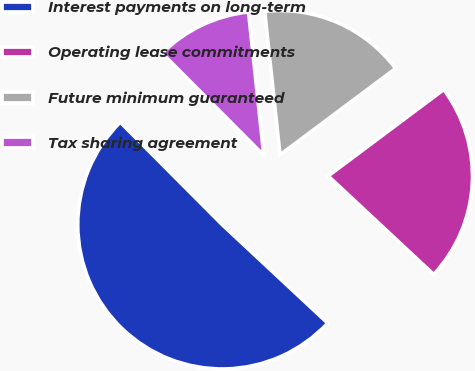Convert chart. <chart><loc_0><loc_0><loc_500><loc_500><pie_chart><fcel>Interest payments on long-term<fcel>Operating lease commitments<fcel>Future minimum guaranteed<fcel>Tax sharing agreement<nl><fcel>50.59%<fcel>22.17%<fcel>16.48%<fcel>10.77%<nl></chart> 